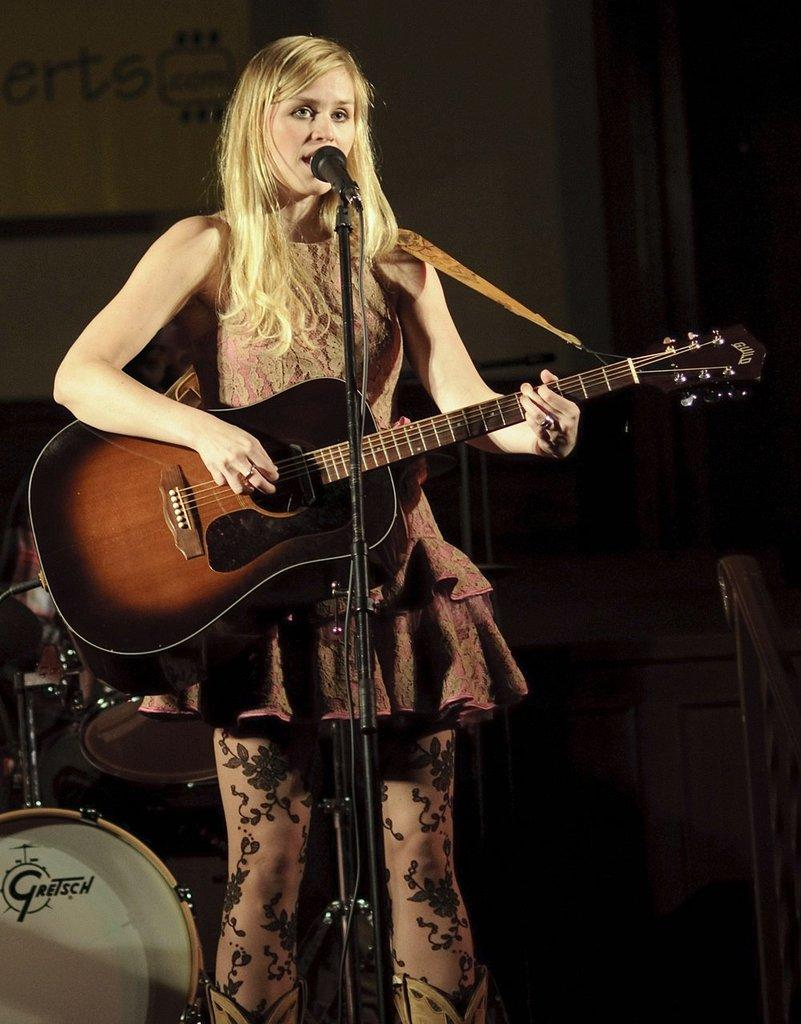What is the woman doing in the image? The woman is singing on a mic and playing a guitar. What other objects can be seen in the image related to the woman's activity? There are musical instruments visible behind the woman. What position does the woman hold in the event depicted in the image? The image does not depict an event, and there is no indication of the woman holding a specific position. How many slaves can be seen in the image? There are no slaves present in the image. 